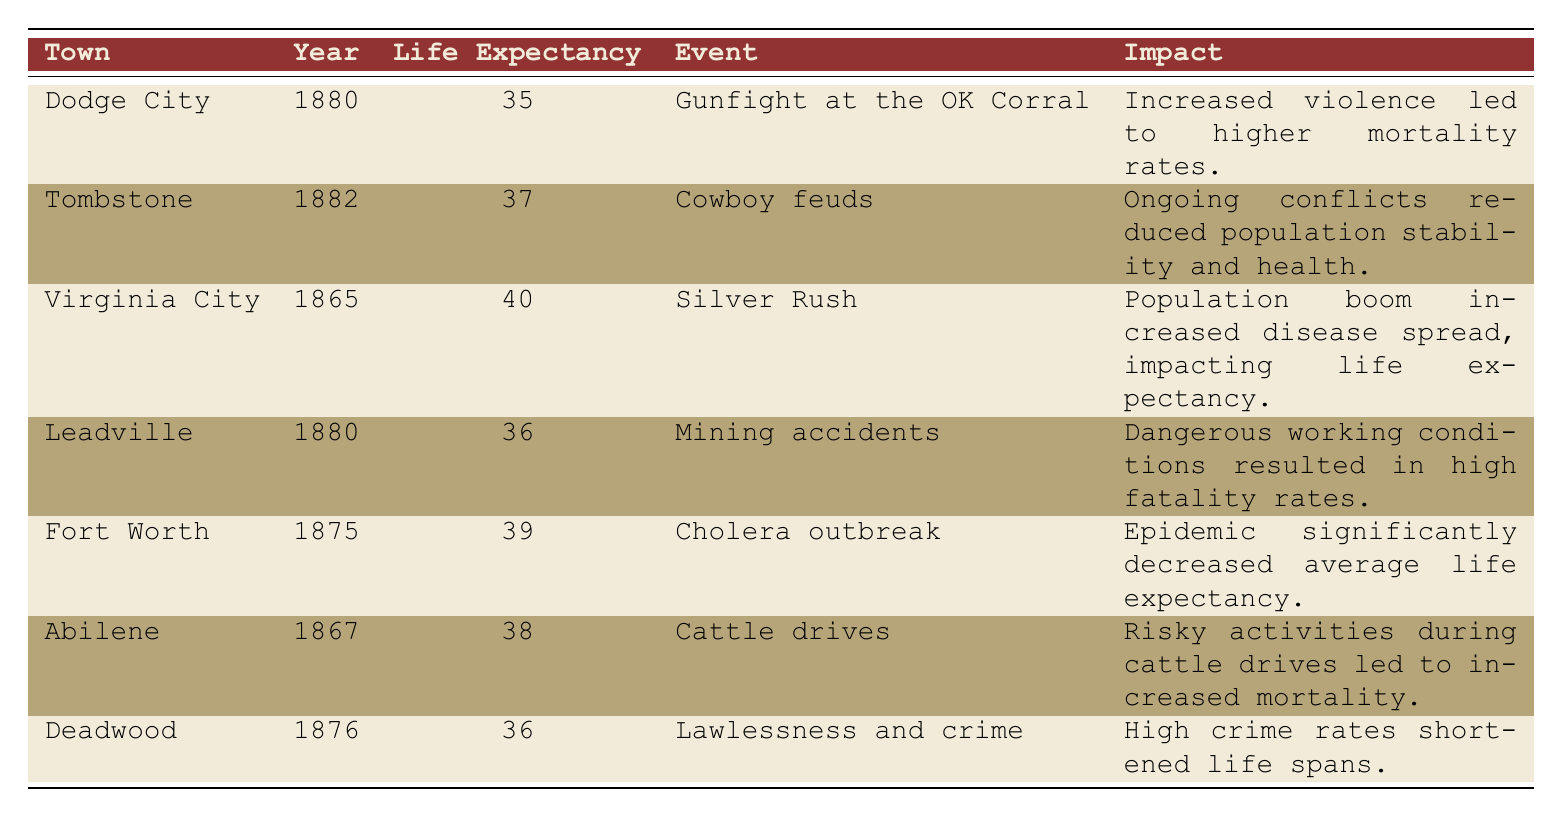What was the life expectancy in Dodge City in 1880? According to the table, the life expectancy in Dodge City for the year 1880 is listed as 35.
Answer: 35 Which town experienced a cholera outbreak in 1875? The table indicates that Fort Worth had a cholera outbreak in the year 1875.
Answer: Fort Worth What event in Virginia City in 1865 contributed to a life expectancy of 40? The event listed for Virginia City in 1865 is the Silver Rush, which is connected to a life expectancy of 40.
Answer: Silver Rush What was the average life expectancy of the towns listed for the year 1880? The life expectancies for the towns in 1880 are 35 (Dodge City), 36 (Leadville). The average is calculated as (35 + 36) / 2 = 35.5.
Answer: 35.5 Did Deadwood have a higher or lower life expectancy than Abilene? Deadwood's life expectancy is 36, while Abilene's is 38. Since 36 is less than 38, Deadwood had a lower life expectancy than Abilene.
Answer: Lower Which events were associated with a decrease in life expectancy? The events listed that led to decreased life expectancy include the cholera outbreak in Fort Worth, the gunfight in Dodge City, cowboy feuds in Tombstone, and lawlessness in Deadwood.
Answer: Cholera outbreak, gunfight, cowboy feuds, lawlessness If we combine the life expectancies of Tombstone and Leadville, what is the total? Tombstone has a life expectancy of 37, and Leadville has 36. The total is 37 + 36 = 73.
Answer: 73 What was the primary impact of the Silver Rush in Virginia City? The primary impact listed for the Silver Rush in Virginia City was an increased spread of diseases, which adversely affected life expectancy.
Answer: Increased disease spread Which town had a life expectancy of 39? The table indicates that Fort Worth had a life expectancy of 39 in the year 1875.
Answer: Fort Worth 